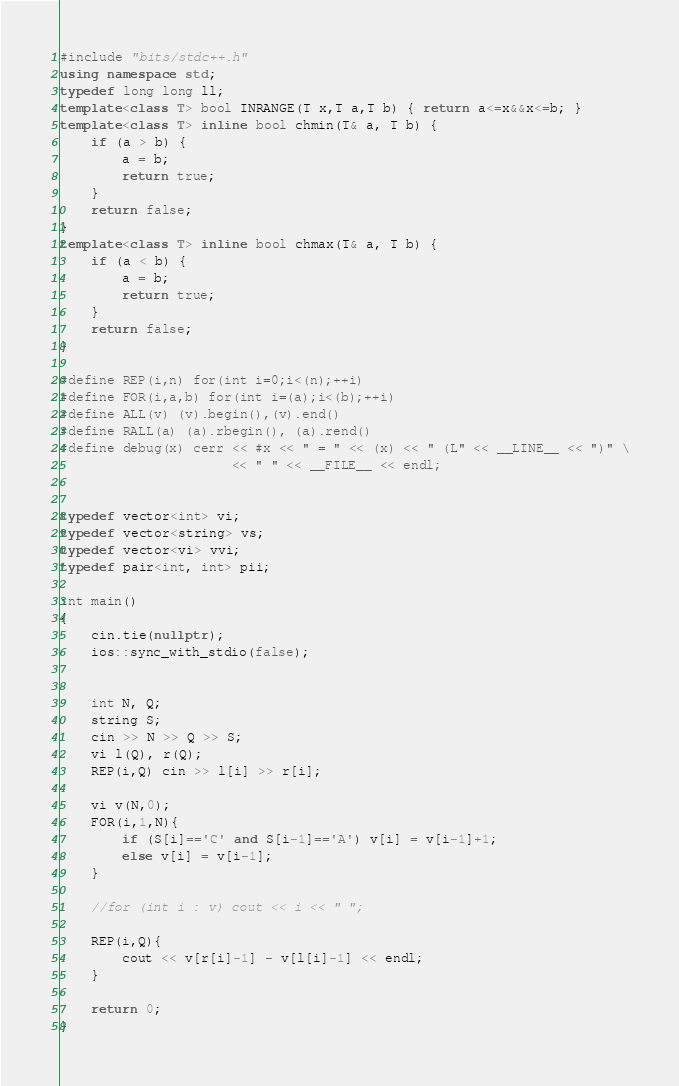<code> <loc_0><loc_0><loc_500><loc_500><_C++_>#include "bits/stdc++.h"
using namespace std;
typedef long long ll;
template<class T> bool INRANGE(T x,T a,T b) { return a<=x&&x<=b; }
template<class T> inline bool chmin(T& a, T b) {
    if (a > b) {
        a = b;
        return true;
    }
    return false;
}
template<class T> inline bool chmax(T& a, T b) {
    if (a < b) {
        a = b;
        return true;
    }
    return false;
}

#define REP(i,n) for(int i=0;i<(n);++i)
#define FOR(i,a,b) for(int i=(a);i<(b);++i)
#define ALL(v) (v).begin(),(v).end()
#define RALL(a) (a).rbegin(), (a).rend()
#define debug(x) cerr << #x << " = " << (x) << " (L" << __LINE__ << ")" \
                      << " " << __FILE__ << endl;


typedef vector<int> vi;
typedef vector<string> vs;
typedef vector<vi> vvi;
typedef pair<int, int> pii;

int main()
{
    cin.tie(nullptr);
    ios::sync_with_stdio(false);


    int N, Q;
    string S;
    cin >> N >> Q >> S;
    vi l(Q), r(Q);
    REP(i,Q) cin >> l[i] >> r[i];

    vi v(N,0);
    FOR(i,1,N){
        if (S[i]=='C' and S[i-1]=='A') v[i] = v[i-1]+1;
        else v[i] = v[i-1];
    }

    //for (int i : v) cout << i << " ";

    REP(i,Q){
        cout << v[r[i]-1] - v[l[i]-1] << endl;
    }

    return 0;
}</code> 